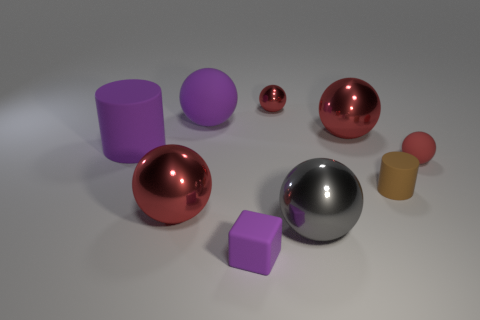What number of other objects are the same shape as the big gray object?
Make the answer very short. 5. Do the tiny object that is behind the tiny matte ball and the matte sphere behind the small rubber sphere have the same color?
Provide a short and direct response. No. What number of large things are either purple cubes or red rubber things?
Provide a succinct answer. 0. What size is the purple object that is the same shape as the large gray shiny object?
Your answer should be compact. Large. Is there any other thing that has the same size as the purple matte sphere?
Make the answer very short. Yes. There is a tiny sphere that is on the right side of the large shiny thing that is behind the red matte thing; what is it made of?
Your response must be concise. Rubber. How many matte things are red things or brown objects?
Give a very brief answer. 2. The small rubber object that is the same shape as the small metal object is what color?
Give a very brief answer. Red. How many matte cylinders have the same color as the block?
Offer a terse response. 1. Are there any red metal objects left of the tiny purple matte cube in front of the large gray metal thing?
Offer a terse response. Yes. 